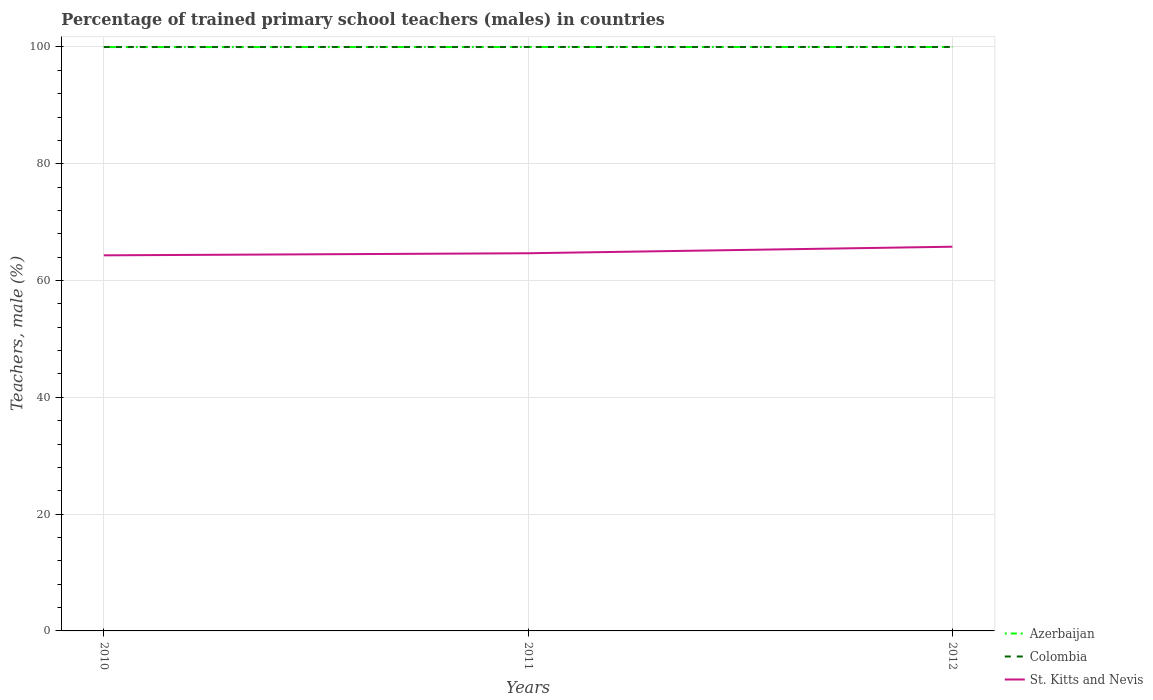Does the line corresponding to Colombia intersect with the line corresponding to St. Kitts and Nevis?
Make the answer very short. No. Across all years, what is the maximum percentage of trained primary school teachers (males) in Colombia?
Offer a terse response. 100. In which year was the percentage of trained primary school teachers (males) in St. Kitts and Nevis maximum?
Offer a very short reply. 2010. What is the difference between the highest and the second highest percentage of trained primary school teachers (males) in St. Kitts and Nevis?
Your response must be concise. 1.47. Is the percentage of trained primary school teachers (males) in Colombia strictly greater than the percentage of trained primary school teachers (males) in St. Kitts and Nevis over the years?
Provide a succinct answer. No. How many lines are there?
Make the answer very short. 3. Are the values on the major ticks of Y-axis written in scientific E-notation?
Keep it short and to the point. No. Where does the legend appear in the graph?
Your answer should be very brief. Bottom right. How are the legend labels stacked?
Your answer should be very brief. Vertical. What is the title of the graph?
Keep it short and to the point. Percentage of trained primary school teachers (males) in countries. Does "East Asia (all income levels)" appear as one of the legend labels in the graph?
Your response must be concise. No. What is the label or title of the Y-axis?
Ensure brevity in your answer.  Teachers, male (%). What is the Teachers, male (%) of Azerbaijan in 2010?
Give a very brief answer. 99.99. What is the Teachers, male (%) of St. Kitts and Nevis in 2010?
Provide a succinct answer. 64.32. What is the Teachers, male (%) of Azerbaijan in 2011?
Keep it short and to the point. 99.99. What is the Teachers, male (%) in Colombia in 2011?
Offer a very short reply. 100. What is the Teachers, male (%) of St. Kitts and Nevis in 2011?
Your answer should be very brief. 64.68. What is the Teachers, male (%) of Azerbaijan in 2012?
Provide a succinct answer. 99.99. What is the Teachers, male (%) in St. Kitts and Nevis in 2012?
Offer a very short reply. 65.8. Across all years, what is the maximum Teachers, male (%) of Azerbaijan?
Offer a very short reply. 99.99. Across all years, what is the maximum Teachers, male (%) of Colombia?
Provide a short and direct response. 100. Across all years, what is the maximum Teachers, male (%) in St. Kitts and Nevis?
Make the answer very short. 65.8. Across all years, what is the minimum Teachers, male (%) in Azerbaijan?
Provide a short and direct response. 99.99. Across all years, what is the minimum Teachers, male (%) of St. Kitts and Nevis?
Ensure brevity in your answer.  64.32. What is the total Teachers, male (%) of Azerbaijan in the graph?
Your response must be concise. 299.97. What is the total Teachers, male (%) of Colombia in the graph?
Make the answer very short. 300. What is the total Teachers, male (%) in St. Kitts and Nevis in the graph?
Your answer should be very brief. 194.8. What is the difference between the Teachers, male (%) of Azerbaijan in 2010 and that in 2011?
Make the answer very short. -0.01. What is the difference between the Teachers, male (%) of St. Kitts and Nevis in 2010 and that in 2011?
Give a very brief answer. -0.35. What is the difference between the Teachers, male (%) in Azerbaijan in 2010 and that in 2012?
Offer a very short reply. -0.01. What is the difference between the Teachers, male (%) of St. Kitts and Nevis in 2010 and that in 2012?
Make the answer very short. -1.47. What is the difference between the Teachers, male (%) of Azerbaijan in 2011 and that in 2012?
Ensure brevity in your answer.  -0. What is the difference between the Teachers, male (%) in St. Kitts and Nevis in 2011 and that in 2012?
Provide a short and direct response. -1.12. What is the difference between the Teachers, male (%) in Azerbaijan in 2010 and the Teachers, male (%) in Colombia in 2011?
Offer a very short reply. -0.01. What is the difference between the Teachers, male (%) in Azerbaijan in 2010 and the Teachers, male (%) in St. Kitts and Nevis in 2011?
Provide a short and direct response. 35.31. What is the difference between the Teachers, male (%) in Colombia in 2010 and the Teachers, male (%) in St. Kitts and Nevis in 2011?
Give a very brief answer. 35.32. What is the difference between the Teachers, male (%) in Azerbaijan in 2010 and the Teachers, male (%) in Colombia in 2012?
Give a very brief answer. -0.01. What is the difference between the Teachers, male (%) of Azerbaijan in 2010 and the Teachers, male (%) of St. Kitts and Nevis in 2012?
Your response must be concise. 34.19. What is the difference between the Teachers, male (%) in Colombia in 2010 and the Teachers, male (%) in St. Kitts and Nevis in 2012?
Your answer should be compact. 34.2. What is the difference between the Teachers, male (%) of Azerbaijan in 2011 and the Teachers, male (%) of Colombia in 2012?
Provide a short and direct response. -0.01. What is the difference between the Teachers, male (%) of Azerbaijan in 2011 and the Teachers, male (%) of St. Kitts and Nevis in 2012?
Make the answer very short. 34.2. What is the difference between the Teachers, male (%) in Colombia in 2011 and the Teachers, male (%) in St. Kitts and Nevis in 2012?
Offer a terse response. 34.2. What is the average Teachers, male (%) in Azerbaijan per year?
Ensure brevity in your answer.  99.99. What is the average Teachers, male (%) in St. Kitts and Nevis per year?
Ensure brevity in your answer.  64.93. In the year 2010, what is the difference between the Teachers, male (%) of Azerbaijan and Teachers, male (%) of Colombia?
Ensure brevity in your answer.  -0.01. In the year 2010, what is the difference between the Teachers, male (%) of Azerbaijan and Teachers, male (%) of St. Kitts and Nevis?
Your response must be concise. 35.66. In the year 2010, what is the difference between the Teachers, male (%) in Colombia and Teachers, male (%) in St. Kitts and Nevis?
Offer a terse response. 35.68. In the year 2011, what is the difference between the Teachers, male (%) of Azerbaijan and Teachers, male (%) of Colombia?
Your answer should be compact. -0.01. In the year 2011, what is the difference between the Teachers, male (%) in Azerbaijan and Teachers, male (%) in St. Kitts and Nevis?
Keep it short and to the point. 35.32. In the year 2011, what is the difference between the Teachers, male (%) in Colombia and Teachers, male (%) in St. Kitts and Nevis?
Provide a short and direct response. 35.32. In the year 2012, what is the difference between the Teachers, male (%) of Azerbaijan and Teachers, male (%) of Colombia?
Offer a terse response. -0.01. In the year 2012, what is the difference between the Teachers, male (%) in Azerbaijan and Teachers, male (%) in St. Kitts and Nevis?
Provide a short and direct response. 34.2. In the year 2012, what is the difference between the Teachers, male (%) in Colombia and Teachers, male (%) in St. Kitts and Nevis?
Provide a short and direct response. 34.2. What is the ratio of the Teachers, male (%) in Azerbaijan in 2010 to that in 2011?
Offer a terse response. 1. What is the ratio of the Teachers, male (%) in Colombia in 2010 to that in 2011?
Provide a short and direct response. 1. What is the ratio of the Teachers, male (%) in St. Kitts and Nevis in 2010 to that in 2011?
Make the answer very short. 0.99. What is the ratio of the Teachers, male (%) of Azerbaijan in 2010 to that in 2012?
Offer a very short reply. 1. What is the ratio of the Teachers, male (%) in St. Kitts and Nevis in 2010 to that in 2012?
Ensure brevity in your answer.  0.98. What is the ratio of the Teachers, male (%) of Azerbaijan in 2011 to that in 2012?
Ensure brevity in your answer.  1. What is the ratio of the Teachers, male (%) of St. Kitts and Nevis in 2011 to that in 2012?
Offer a terse response. 0.98. What is the difference between the highest and the second highest Teachers, male (%) of Azerbaijan?
Ensure brevity in your answer.  0. What is the difference between the highest and the second highest Teachers, male (%) of St. Kitts and Nevis?
Offer a terse response. 1.12. What is the difference between the highest and the lowest Teachers, male (%) in Azerbaijan?
Your answer should be compact. 0.01. What is the difference between the highest and the lowest Teachers, male (%) in Colombia?
Offer a terse response. 0. What is the difference between the highest and the lowest Teachers, male (%) of St. Kitts and Nevis?
Provide a short and direct response. 1.47. 